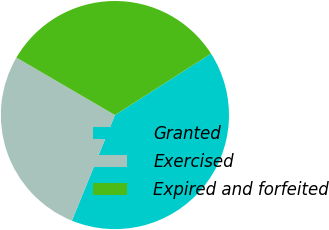Convert chart. <chart><loc_0><loc_0><loc_500><loc_500><pie_chart><fcel>Granted<fcel>Exercised<fcel>Expired and forfeited<nl><fcel>40.22%<fcel>27.25%<fcel>32.54%<nl></chart> 